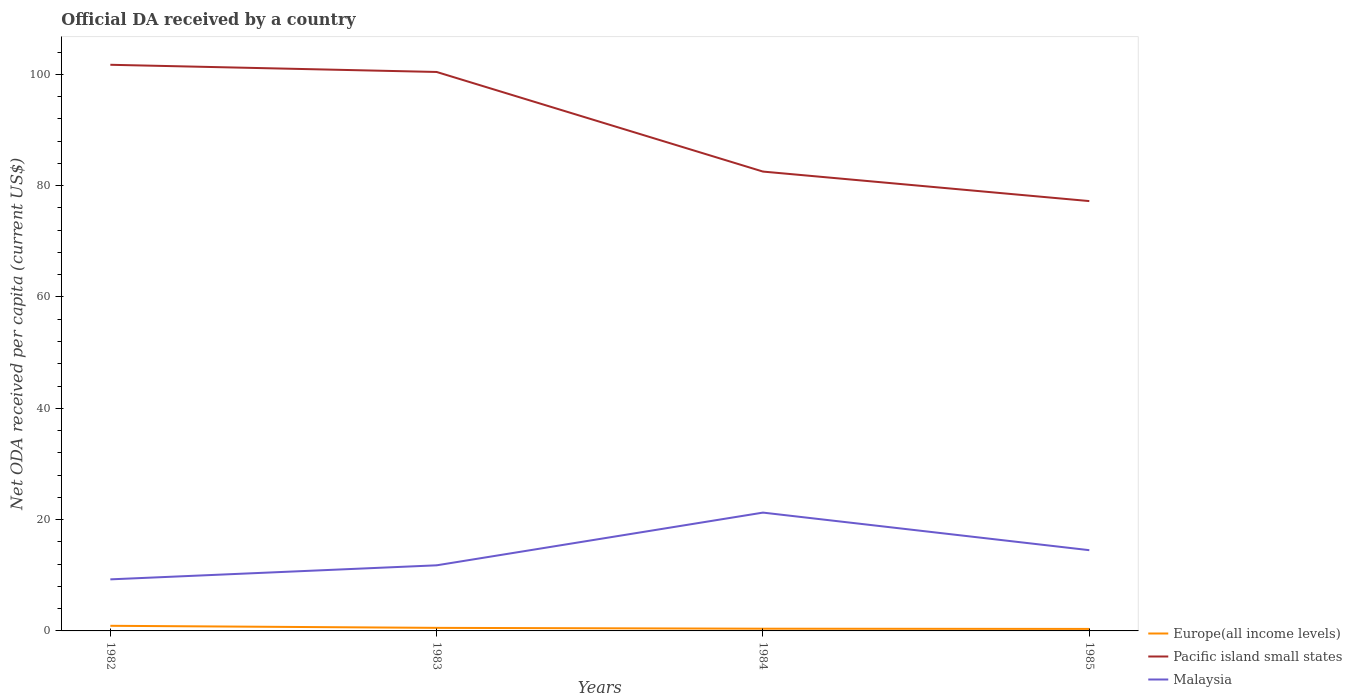Across all years, what is the maximum ODA received in in Malaysia?
Provide a succinct answer. 9.26. What is the total ODA received in in Europe(all income levels) in the graph?
Provide a short and direct response. 0.37. What is the difference between the highest and the second highest ODA received in in Malaysia?
Your response must be concise. 11.99. Is the ODA received in in Europe(all income levels) strictly greater than the ODA received in in Malaysia over the years?
Your answer should be compact. Yes. Are the values on the major ticks of Y-axis written in scientific E-notation?
Make the answer very short. No. How many legend labels are there?
Give a very brief answer. 3. How are the legend labels stacked?
Ensure brevity in your answer.  Vertical. What is the title of the graph?
Offer a terse response. Official DA received by a country. Does "France" appear as one of the legend labels in the graph?
Provide a succinct answer. No. What is the label or title of the Y-axis?
Give a very brief answer. Net ODA received per capita (current US$). What is the Net ODA received per capita (current US$) in Europe(all income levels) in 1982?
Your answer should be very brief. 0.92. What is the Net ODA received per capita (current US$) in Pacific island small states in 1982?
Ensure brevity in your answer.  101.71. What is the Net ODA received per capita (current US$) of Malaysia in 1982?
Your answer should be compact. 9.26. What is the Net ODA received per capita (current US$) in Europe(all income levels) in 1983?
Offer a terse response. 0.55. What is the Net ODA received per capita (current US$) of Pacific island small states in 1983?
Offer a terse response. 100.42. What is the Net ODA received per capita (current US$) in Malaysia in 1983?
Ensure brevity in your answer.  11.79. What is the Net ODA received per capita (current US$) in Europe(all income levels) in 1984?
Ensure brevity in your answer.  0.4. What is the Net ODA received per capita (current US$) in Pacific island small states in 1984?
Give a very brief answer. 82.52. What is the Net ODA received per capita (current US$) of Malaysia in 1984?
Your answer should be compact. 21.26. What is the Net ODA received per capita (current US$) of Europe(all income levels) in 1985?
Provide a succinct answer. 0.36. What is the Net ODA received per capita (current US$) of Pacific island small states in 1985?
Offer a very short reply. 77.22. What is the Net ODA received per capita (current US$) in Malaysia in 1985?
Keep it short and to the point. 14.51. Across all years, what is the maximum Net ODA received per capita (current US$) in Europe(all income levels)?
Offer a terse response. 0.92. Across all years, what is the maximum Net ODA received per capita (current US$) of Pacific island small states?
Your response must be concise. 101.71. Across all years, what is the maximum Net ODA received per capita (current US$) in Malaysia?
Make the answer very short. 21.26. Across all years, what is the minimum Net ODA received per capita (current US$) in Europe(all income levels)?
Ensure brevity in your answer.  0.36. Across all years, what is the minimum Net ODA received per capita (current US$) of Pacific island small states?
Keep it short and to the point. 77.22. Across all years, what is the minimum Net ODA received per capita (current US$) in Malaysia?
Your response must be concise. 9.26. What is the total Net ODA received per capita (current US$) in Europe(all income levels) in the graph?
Give a very brief answer. 2.23. What is the total Net ODA received per capita (current US$) of Pacific island small states in the graph?
Make the answer very short. 361.88. What is the total Net ODA received per capita (current US$) of Malaysia in the graph?
Offer a very short reply. 56.81. What is the difference between the Net ODA received per capita (current US$) in Europe(all income levels) in 1982 and that in 1983?
Provide a succinct answer. 0.37. What is the difference between the Net ODA received per capita (current US$) in Pacific island small states in 1982 and that in 1983?
Give a very brief answer. 1.29. What is the difference between the Net ODA received per capita (current US$) of Malaysia in 1982 and that in 1983?
Offer a terse response. -2.52. What is the difference between the Net ODA received per capita (current US$) of Europe(all income levels) in 1982 and that in 1984?
Offer a terse response. 0.52. What is the difference between the Net ODA received per capita (current US$) of Pacific island small states in 1982 and that in 1984?
Give a very brief answer. 19.19. What is the difference between the Net ODA received per capita (current US$) of Malaysia in 1982 and that in 1984?
Give a very brief answer. -11.99. What is the difference between the Net ODA received per capita (current US$) of Europe(all income levels) in 1982 and that in 1985?
Your answer should be very brief. 0.56. What is the difference between the Net ODA received per capita (current US$) in Pacific island small states in 1982 and that in 1985?
Offer a terse response. 24.49. What is the difference between the Net ODA received per capita (current US$) in Malaysia in 1982 and that in 1985?
Your response must be concise. -5.24. What is the difference between the Net ODA received per capita (current US$) of Europe(all income levels) in 1983 and that in 1984?
Provide a succinct answer. 0.15. What is the difference between the Net ODA received per capita (current US$) in Pacific island small states in 1983 and that in 1984?
Ensure brevity in your answer.  17.89. What is the difference between the Net ODA received per capita (current US$) in Malaysia in 1983 and that in 1984?
Your answer should be compact. -9.47. What is the difference between the Net ODA received per capita (current US$) of Europe(all income levels) in 1983 and that in 1985?
Offer a terse response. 0.19. What is the difference between the Net ODA received per capita (current US$) of Pacific island small states in 1983 and that in 1985?
Provide a succinct answer. 23.2. What is the difference between the Net ODA received per capita (current US$) of Malaysia in 1983 and that in 1985?
Offer a terse response. -2.72. What is the difference between the Net ODA received per capita (current US$) of Pacific island small states in 1984 and that in 1985?
Your answer should be very brief. 5.3. What is the difference between the Net ODA received per capita (current US$) of Malaysia in 1984 and that in 1985?
Your response must be concise. 6.75. What is the difference between the Net ODA received per capita (current US$) of Europe(all income levels) in 1982 and the Net ODA received per capita (current US$) of Pacific island small states in 1983?
Your answer should be compact. -99.5. What is the difference between the Net ODA received per capita (current US$) in Europe(all income levels) in 1982 and the Net ODA received per capita (current US$) in Malaysia in 1983?
Offer a very short reply. -10.87. What is the difference between the Net ODA received per capita (current US$) in Pacific island small states in 1982 and the Net ODA received per capita (current US$) in Malaysia in 1983?
Your response must be concise. 89.92. What is the difference between the Net ODA received per capita (current US$) of Europe(all income levels) in 1982 and the Net ODA received per capita (current US$) of Pacific island small states in 1984?
Offer a terse response. -81.6. What is the difference between the Net ODA received per capita (current US$) in Europe(all income levels) in 1982 and the Net ODA received per capita (current US$) in Malaysia in 1984?
Keep it short and to the point. -20.34. What is the difference between the Net ODA received per capita (current US$) in Pacific island small states in 1982 and the Net ODA received per capita (current US$) in Malaysia in 1984?
Your response must be concise. 80.45. What is the difference between the Net ODA received per capita (current US$) of Europe(all income levels) in 1982 and the Net ODA received per capita (current US$) of Pacific island small states in 1985?
Provide a short and direct response. -76.3. What is the difference between the Net ODA received per capita (current US$) in Europe(all income levels) in 1982 and the Net ODA received per capita (current US$) in Malaysia in 1985?
Offer a terse response. -13.59. What is the difference between the Net ODA received per capita (current US$) in Pacific island small states in 1982 and the Net ODA received per capita (current US$) in Malaysia in 1985?
Provide a short and direct response. 87.21. What is the difference between the Net ODA received per capita (current US$) of Europe(all income levels) in 1983 and the Net ODA received per capita (current US$) of Pacific island small states in 1984?
Your response must be concise. -81.97. What is the difference between the Net ODA received per capita (current US$) in Europe(all income levels) in 1983 and the Net ODA received per capita (current US$) in Malaysia in 1984?
Make the answer very short. -20.71. What is the difference between the Net ODA received per capita (current US$) in Pacific island small states in 1983 and the Net ODA received per capita (current US$) in Malaysia in 1984?
Provide a succinct answer. 79.16. What is the difference between the Net ODA received per capita (current US$) of Europe(all income levels) in 1983 and the Net ODA received per capita (current US$) of Pacific island small states in 1985?
Your answer should be compact. -76.67. What is the difference between the Net ODA received per capita (current US$) of Europe(all income levels) in 1983 and the Net ODA received per capita (current US$) of Malaysia in 1985?
Your answer should be very brief. -13.95. What is the difference between the Net ODA received per capita (current US$) in Pacific island small states in 1983 and the Net ODA received per capita (current US$) in Malaysia in 1985?
Offer a terse response. 85.91. What is the difference between the Net ODA received per capita (current US$) of Europe(all income levels) in 1984 and the Net ODA received per capita (current US$) of Pacific island small states in 1985?
Your response must be concise. -76.82. What is the difference between the Net ODA received per capita (current US$) of Europe(all income levels) in 1984 and the Net ODA received per capita (current US$) of Malaysia in 1985?
Give a very brief answer. -14.11. What is the difference between the Net ODA received per capita (current US$) in Pacific island small states in 1984 and the Net ODA received per capita (current US$) in Malaysia in 1985?
Offer a terse response. 68.02. What is the average Net ODA received per capita (current US$) of Europe(all income levels) per year?
Your response must be concise. 0.56. What is the average Net ODA received per capita (current US$) in Pacific island small states per year?
Give a very brief answer. 90.47. What is the average Net ODA received per capita (current US$) in Malaysia per year?
Your response must be concise. 14.2. In the year 1982, what is the difference between the Net ODA received per capita (current US$) in Europe(all income levels) and Net ODA received per capita (current US$) in Pacific island small states?
Ensure brevity in your answer.  -100.79. In the year 1982, what is the difference between the Net ODA received per capita (current US$) in Europe(all income levels) and Net ODA received per capita (current US$) in Malaysia?
Keep it short and to the point. -8.34. In the year 1982, what is the difference between the Net ODA received per capita (current US$) of Pacific island small states and Net ODA received per capita (current US$) of Malaysia?
Provide a short and direct response. 92.45. In the year 1983, what is the difference between the Net ODA received per capita (current US$) in Europe(all income levels) and Net ODA received per capita (current US$) in Pacific island small states?
Offer a very short reply. -99.87. In the year 1983, what is the difference between the Net ODA received per capita (current US$) of Europe(all income levels) and Net ODA received per capita (current US$) of Malaysia?
Ensure brevity in your answer.  -11.24. In the year 1983, what is the difference between the Net ODA received per capita (current US$) of Pacific island small states and Net ODA received per capita (current US$) of Malaysia?
Ensure brevity in your answer.  88.63. In the year 1984, what is the difference between the Net ODA received per capita (current US$) in Europe(all income levels) and Net ODA received per capita (current US$) in Pacific island small states?
Offer a very short reply. -82.12. In the year 1984, what is the difference between the Net ODA received per capita (current US$) of Europe(all income levels) and Net ODA received per capita (current US$) of Malaysia?
Offer a terse response. -20.86. In the year 1984, what is the difference between the Net ODA received per capita (current US$) in Pacific island small states and Net ODA received per capita (current US$) in Malaysia?
Keep it short and to the point. 61.27. In the year 1985, what is the difference between the Net ODA received per capita (current US$) of Europe(all income levels) and Net ODA received per capita (current US$) of Pacific island small states?
Keep it short and to the point. -76.86. In the year 1985, what is the difference between the Net ODA received per capita (current US$) of Europe(all income levels) and Net ODA received per capita (current US$) of Malaysia?
Your answer should be compact. -14.15. In the year 1985, what is the difference between the Net ODA received per capita (current US$) in Pacific island small states and Net ODA received per capita (current US$) in Malaysia?
Make the answer very short. 62.72. What is the ratio of the Net ODA received per capita (current US$) of Europe(all income levels) in 1982 to that in 1983?
Offer a terse response. 1.67. What is the ratio of the Net ODA received per capita (current US$) of Pacific island small states in 1982 to that in 1983?
Provide a short and direct response. 1.01. What is the ratio of the Net ODA received per capita (current US$) in Malaysia in 1982 to that in 1983?
Offer a terse response. 0.79. What is the ratio of the Net ODA received per capita (current US$) of Europe(all income levels) in 1982 to that in 1984?
Your response must be concise. 2.3. What is the ratio of the Net ODA received per capita (current US$) in Pacific island small states in 1982 to that in 1984?
Your response must be concise. 1.23. What is the ratio of the Net ODA received per capita (current US$) of Malaysia in 1982 to that in 1984?
Your answer should be very brief. 0.44. What is the ratio of the Net ODA received per capita (current US$) in Europe(all income levels) in 1982 to that in 1985?
Offer a very short reply. 2.56. What is the ratio of the Net ODA received per capita (current US$) of Pacific island small states in 1982 to that in 1985?
Offer a very short reply. 1.32. What is the ratio of the Net ODA received per capita (current US$) in Malaysia in 1982 to that in 1985?
Offer a very short reply. 0.64. What is the ratio of the Net ODA received per capita (current US$) in Europe(all income levels) in 1983 to that in 1984?
Offer a terse response. 1.38. What is the ratio of the Net ODA received per capita (current US$) of Pacific island small states in 1983 to that in 1984?
Keep it short and to the point. 1.22. What is the ratio of the Net ODA received per capita (current US$) of Malaysia in 1983 to that in 1984?
Your response must be concise. 0.55. What is the ratio of the Net ODA received per capita (current US$) in Europe(all income levels) in 1983 to that in 1985?
Ensure brevity in your answer.  1.53. What is the ratio of the Net ODA received per capita (current US$) of Pacific island small states in 1983 to that in 1985?
Make the answer very short. 1.3. What is the ratio of the Net ODA received per capita (current US$) in Malaysia in 1983 to that in 1985?
Provide a short and direct response. 0.81. What is the ratio of the Net ODA received per capita (current US$) of Europe(all income levels) in 1984 to that in 1985?
Provide a succinct answer. 1.11. What is the ratio of the Net ODA received per capita (current US$) in Pacific island small states in 1984 to that in 1985?
Offer a very short reply. 1.07. What is the ratio of the Net ODA received per capita (current US$) in Malaysia in 1984 to that in 1985?
Keep it short and to the point. 1.47. What is the difference between the highest and the second highest Net ODA received per capita (current US$) of Europe(all income levels)?
Your response must be concise. 0.37. What is the difference between the highest and the second highest Net ODA received per capita (current US$) of Pacific island small states?
Offer a terse response. 1.29. What is the difference between the highest and the second highest Net ODA received per capita (current US$) of Malaysia?
Your answer should be compact. 6.75. What is the difference between the highest and the lowest Net ODA received per capita (current US$) of Europe(all income levels)?
Ensure brevity in your answer.  0.56. What is the difference between the highest and the lowest Net ODA received per capita (current US$) in Pacific island small states?
Ensure brevity in your answer.  24.49. What is the difference between the highest and the lowest Net ODA received per capita (current US$) of Malaysia?
Provide a succinct answer. 11.99. 